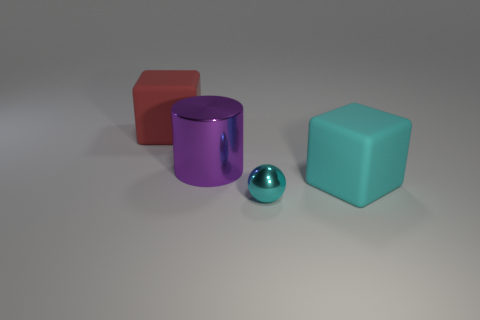Is the number of shiny spheres the same as the number of big green metal balls?
Ensure brevity in your answer.  No. There is a red object that is the same shape as the cyan matte thing; what is its size?
Your answer should be compact. Large. What number of large purple cylinders are to the right of the big cube that is in front of the big cylinder that is in front of the red matte block?
Your answer should be compact. 0. Are there an equal number of cyan balls on the right side of the tiny ball and big green blocks?
Make the answer very short. Yes. How many cylinders are either tiny metallic things or purple matte things?
Give a very brief answer. 0. Does the small shiny thing have the same color as the large cylinder?
Offer a terse response. No. Is the number of tiny cyan metal things left of the sphere the same as the number of cyan matte blocks to the left of the large cyan cube?
Give a very brief answer. Yes. The cylinder has what color?
Offer a terse response. Purple. How many objects are large rubber cubes that are behind the purple cylinder or large gray metal spheres?
Ensure brevity in your answer.  1. There is a block that is on the right side of the red cube; does it have the same size as the shiny object in front of the large cylinder?
Your answer should be very brief. No. 